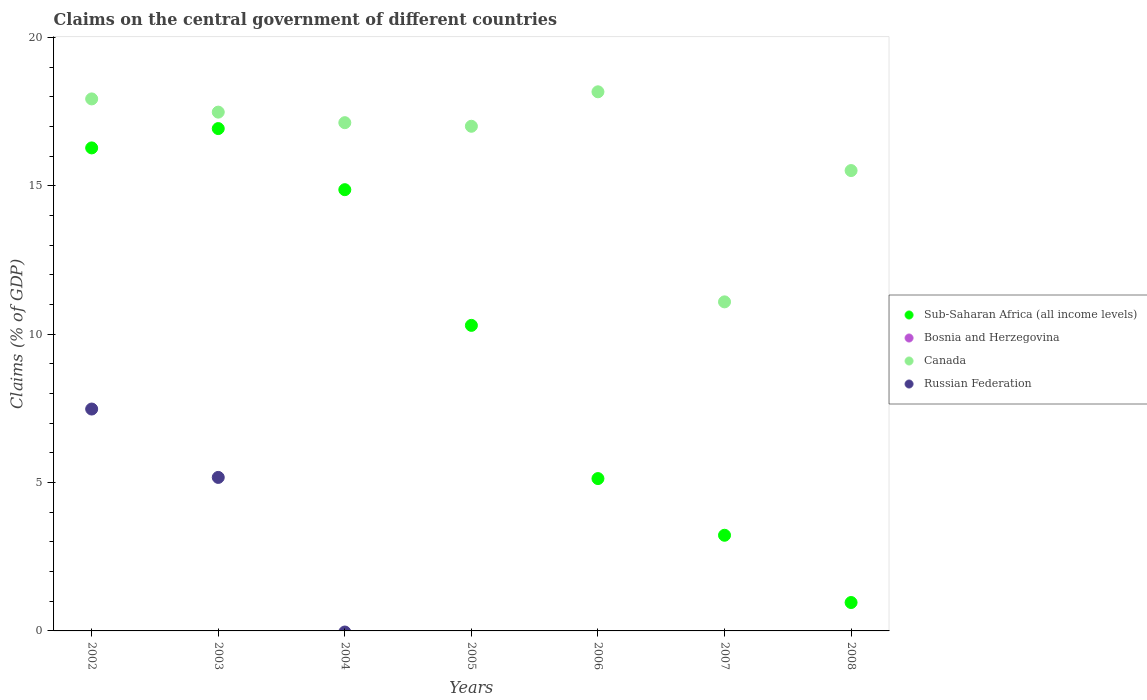What is the percentage of GDP claimed on the central government in Canada in 2004?
Give a very brief answer. 17.13. Across all years, what is the maximum percentage of GDP claimed on the central government in Russian Federation?
Make the answer very short. 7.48. Across all years, what is the minimum percentage of GDP claimed on the central government in Canada?
Your response must be concise. 11.09. What is the total percentage of GDP claimed on the central government in Canada in the graph?
Your answer should be compact. 114.3. What is the difference between the percentage of GDP claimed on the central government in Sub-Saharan Africa (all income levels) in 2007 and that in 2008?
Offer a very short reply. 2.27. What is the difference between the percentage of GDP claimed on the central government in Bosnia and Herzegovina in 2002 and the percentage of GDP claimed on the central government in Canada in 2007?
Your answer should be very brief. -11.09. What is the average percentage of GDP claimed on the central government in Canada per year?
Offer a very short reply. 16.33. In the year 2004, what is the difference between the percentage of GDP claimed on the central government in Sub-Saharan Africa (all income levels) and percentage of GDP claimed on the central government in Canada?
Give a very brief answer. -2.26. In how many years, is the percentage of GDP claimed on the central government in Canada greater than 19 %?
Provide a short and direct response. 0. What is the ratio of the percentage of GDP claimed on the central government in Sub-Saharan Africa (all income levels) in 2002 to that in 2005?
Offer a very short reply. 1.58. What is the difference between the highest and the second highest percentage of GDP claimed on the central government in Sub-Saharan Africa (all income levels)?
Your answer should be compact. 0.65. What is the difference between the highest and the lowest percentage of GDP claimed on the central government in Canada?
Provide a succinct answer. 7.08. Is it the case that in every year, the sum of the percentage of GDP claimed on the central government in Sub-Saharan Africa (all income levels) and percentage of GDP claimed on the central government in Russian Federation  is greater than the sum of percentage of GDP claimed on the central government in Canada and percentage of GDP claimed on the central government in Bosnia and Herzegovina?
Your answer should be very brief. No. Does the percentage of GDP claimed on the central government in Canada monotonically increase over the years?
Give a very brief answer. No. How many years are there in the graph?
Keep it short and to the point. 7. What is the difference between two consecutive major ticks on the Y-axis?
Ensure brevity in your answer.  5. Does the graph contain grids?
Offer a terse response. No. How many legend labels are there?
Give a very brief answer. 4. How are the legend labels stacked?
Keep it short and to the point. Vertical. What is the title of the graph?
Provide a short and direct response. Claims on the central government of different countries. Does "Faeroe Islands" appear as one of the legend labels in the graph?
Make the answer very short. No. What is the label or title of the Y-axis?
Provide a short and direct response. Claims (% of GDP). What is the Claims (% of GDP) in Sub-Saharan Africa (all income levels) in 2002?
Give a very brief answer. 16.28. What is the Claims (% of GDP) of Bosnia and Herzegovina in 2002?
Your response must be concise. 0. What is the Claims (% of GDP) in Canada in 2002?
Offer a terse response. 17.93. What is the Claims (% of GDP) of Russian Federation in 2002?
Your answer should be compact. 7.48. What is the Claims (% of GDP) in Sub-Saharan Africa (all income levels) in 2003?
Your answer should be compact. 16.93. What is the Claims (% of GDP) in Bosnia and Herzegovina in 2003?
Provide a succinct answer. 0. What is the Claims (% of GDP) in Canada in 2003?
Give a very brief answer. 17.48. What is the Claims (% of GDP) of Russian Federation in 2003?
Your answer should be very brief. 5.17. What is the Claims (% of GDP) in Sub-Saharan Africa (all income levels) in 2004?
Provide a short and direct response. 14.87. What is the Claims (% of GDP) of Canada in 2004?
Your response must be concise. 17.13. What is the Claims (% of GDP) of Russian Federation in 2004?
Your response must be concise. 0. What is the Claims (% of GDP) of Sub-Saharan Africa (all income levels) in 2005?
Your answer should be compact. 10.3. What is the Claims (% of GDP) of Canada in 2005?
Keep it short and to the point. 17. What is the Claims (% of GDP) in Russian Federation in 2005?
Give a very brief answer. 0. What is the Claims (% of GDP) in Sub-Saharan Africa (all income levels) in 2006?
Your response must be concise. 5.13. What is the Claims (% of GDP) in Canada in 2006?
Give a very brief answer. 18.17. What is the Claims (% of GDP) of Sub-Saharan Africa (all income levels) in 2007?
Offer a terse response. 3.22. What is the Claims (% of GDP) in Bosnia and Herzegovina in 2007?
Your answer should be compact. 0. What is the Claims (% of GDP) of Canada in 2007?
Ensure brevity in your answer.  11.09. What is the Claims (% of GDP) of Sub-Saharan Africa (all income levels) in 2008?
Your response must be concise. 0.96. What is the Claims (% of GDP) in Bosnia and Herzegovina in 2008?
Your response must be concise. 0. What is the Claims (% of GDP) of Canada in 2008?
Your answer should be compact. 15.51. Across all years, what is the maximum Claims (% of GDP) of Sub-Saharan Africa (all income levels)?
Your answer should be very brief. 16.93. Across all years, what is the maximum Claims (% of GDP) of Canada?
Your answer should be compact. 18.17. Across all years, what is the maximum Claims (% of GDP) of Russian Federation?
Your answer should be very brief. 7.48. Across all years, what is the minimum Claims (% of GDP) in Sub-Saharan Africa (all income levels)?
Offer a terse response. 0.96. Across all years, what is the minimum Claims (% of GDP) of Canada?
Provide a succinct answer. 11.09. Across all years, what is the minimum Claims (% of GDP) in Russian Federation?
Make the answer very short. 0. What is the total Claims (% of GDP) in Sub-Saharan Africa (all income levels) in the graph?
Offer a terse response. 67.68. What is the total Claims (% of GDP) in Canada in the graph?
Offer a terse response. 114.3. What is the total Claims (% of GDP) in Russian Federation in the graph?
Your response must be concise. 12.65. What is the difference between the Claims (% of GDP) of Sub-Saharan Africa (all income levels) in 2002 and that in 2003?
Your answer should be compact. -0.65. What is the difference between the Claims (% of GDP) in Canada in 2002 and that in 2003?
Give a very brief answer. 0.45. What is the difference between the Claims (% of GDP) in Russian Federation in 2002 and that in 2003?
Your answer should be very brief. 2.3. What is the difference between the Claims (% of GDP) of Sub-Saharan Africa (all income levels) in 2002 and that in 2004?
Make the answer very short. 1.41. What is the difference between the Claims (% of GDP) of Canada in 2002 and that in 2004?
Provide a short and direct response. 0.8. What is the difference between the Claims (% of GDP) of Sub-Saharan Africa (all income levels) in 2002 and that in 2005?
Give a very brief answer. 5.98. What is the difference between the Claims (% of GDP) of Canada in 2002 and that in 2005?
Keep it short and to the point. 0.92. What is the difference between the Claims (% of GDP) in Sub-Saharan Africa (all income levels) in 2002 and that in 2006?
Offer a very short reply. 11.14. What is the difference between the Claims (% of GDP) of Canada in 2002 and that in 2006?
Ensure brevity in your answer.  -0.24. What is the difference between the Claims (% of GDP) in Sub-Saharan Africa (all income levels) in 2002 and that in 2007?
Provide a succinct answer. 13.05. What is the difference between the Claims (% of GDP) of Canada in 2002 and that in 2007?
Give a very brief answer. 6.84. What is the difference between the Claims (% of GDP) in Sub-Saharan Africa (all income levels) in 2002 and that in 2008?
Ensure brevity in your answer.  15.32. What is the difference between the Claims (% of GDP) in Canada in 2002 and that in 2008?
Offer a terse response. 2.41. What is the difference between the Claims (% of GDP) in Sub-Saharan Africa (all income levels) in 2003 and that in 2004?
Your answer should be very brief. 2.06. What is the difference between the Claims (% of GDP) of Canada in 2003 and that in 2004?
Ensure brevity in your answer.  0.36. What is the difference between the Claims (% of GDP) of Sub-Saharan Africa (all income levels) in 2003 and that in 2005?
Your answer should be compact. 6.63. What is the difference between the Claims (% of GDP) of Canada in 2003 and that in 2005?
Ensure brevity in your answer.  0.48. What is the difference between the Claims (% of GDP) in Sub-Saharan Africa (all income levels) in 2003 and that in 2006?
Your answer should be very brief. 11.79. What is the difference between the Claims (% of GDP) of Canada in 2003 and that in 2006?
Ensure brevity in your answer.  -0.68. What is the difference between the Claims (% of GDP) in Sub-Saharan Africa (all income levels) in 2003 and that in 2007?
Offer a very short reply. 13.7. What is the difference between the Claims (% of GDP) of Canada in 2003 and that in 2007?
Offer a terse response. 6.39. What is the difference between the Claims (% of GDP) of Sub-Saharan Africa (all income levels) in 2003 and that in 2008?
Give a very brief answer. 15.97. What is the difference between the Claims (% of GDP) of Canada in 2003 and that in 2008?
Your answer should be compact. 1.97. What is the difference between the Claims (% of GDP) of Sub-Saharan Africa (all income levels) in 2004 and that in 2005?
Your answer should be compact. 4.57. What is the difference between the Claims (% of GDP) of Canada in 2004 and that in 2005?
Ensure brevity in your answer.  0.12. What is the difference between the Claims (% of GDP) in Sub-Saharan Africa (all income levels) in 2004 and that in 2006?
Your answer should be compact. 9.73. What is the difference between the Claims (% of GDP) in Canada in 2004 and that in 2006?
Keep it short and to the point. -1.04. What is the difference between the Claims (% of GDP) of Sub-Saharan Africa (all income levels) in 2004 and that in 2007?
Provide a succinct answer. 11.64. What is the difference between the Claims (% of GDP) of Canada in 2004 and that in 2007?
Provide a succinct answer. 6.04. What is the difference between the Claims (% of GDP) in Sub-Saharan Africa (all income levels) in 2004 and that in 2008?
Provide a succinct answer. 13.91. What is the difference between the Claims (% of GDP) in Canada in 2004 and that in 2008?
Ensure brevity in your answer.  1.61. What is the difference between the Claims (% of GDP) of Sub-Saharan Africa (all income levels) in 2005 and that in 2006?
Make the answer very short. 5.16. What is the difference between the Claims (% of GDP) of Canada in 2005 and that in 2006?
Make the answer very short. -1.16. What is the difference between the Claims (% of GDP) in Sub-Saharan Africa (all income levels) in 2005 and that in 2007?
Your answer should be compact. 7.07. What is the difference between the Claims (% of GDP) of Canada in 2005 and that in 2007?
Offer a very short reply. 5.92. What is the difference between the Claims (% of GDP) of Sub-Saharan Africa (all income levels) in 2005 and that in 2008?
Give a very brief answer. 9.34. What is the difference between the Claims (% of GDP) in Canada in 2005 and that in 2008?
Your answer should be compact. 1.49. What is the difference between the Claims (% of GDP) of Sub-Saharan Africa (all income levels) in 2006 and that in 2007?
Your answer should be compact. 1.91. What is the difference between the Claims (% of GDP) of Canada in 2006 and that in 2007?
Offer a terse response. 7.08. What is the difference between the Claims (% of GDP) in Sub-Saharan Africa (all income levels) in 2006 and that in 2008?
Your answer should be very brief. 4.18. What is the difference between the Claims (% of GDP) in Canada in 2006 and that in 2008?
Give a very brief answer. 2.65. What is the difference between the Claims (% of GDP) of Sub-Saharan Africa (all income levels) in 2007 and that in 2008?
Your answer should be very brief. 2.27. What is the difference between the Claims (% of GDP) in Canada in 2007 and that in 2008?
Ensure brevity in your answer.  -4.42. What is the difference between the Claims (% of GDP) of Sub-Saharan Africa (all income levels) in 2002 and the Claims (% of GDP) of Canada in 2003?
Offer a very short reply. -1.21. What is the difference between the Claims (% of GDP) of Sub-Saharan Africa (all income levels) in 2002 and the Claims (% of GDP) of Russian Federation in 2003?
Your answer should be compact. 11.1. What is the difference between the Claims (% of GDP) of Canada in 2002 and the Claims (% of GDP) of Russian Federation in 2003?
Ensure brevity in your answer.  12.75. What is the difference between the Claims (% of GDP) of Sub-Saharan Africa (all income levels) in 2002 and the Claims (% of GDP) of Canada in 2004?
Offer a very short reply. -0.85. What is the difference between the Claims (% of GDP) of Sub-Saharan Africa (all income levels) in 2002 and the Claims (% of GDP) of Canada in 2005?
Make the answer very short. -0.73. What is the difference between the Claims (% of GDP) of Sub-Saharan Africa (all income levels) in 2002 and the Claims (% of GDP) of Canada in 2006?
Provide a succinct answer. -1.89. What is the difference between the Claims (% of GDP) of Sub-Saharan Africa (all income levels) in 2002 and the Claims (% of GDP) of Canada in 2007?
Ensure brevity in your answer.  5.19. What is the difference between the Claims (% of GDP) in Sub-Saharan Africa (all income levels) in 2002 and the Claims (% of GDP) in Canada in 2008?
Provide a succinct answer. 0.76. What is the difference between the Claims (% of GDP) in Sub-Saharan Africa (all income levels) in 2003 and the Claims (% of GDP) in Canada in 2004?
Provide a succinct answer. -0.2. What is the difference between the Claims (% of GDP) in Sub-Saharan Africa (all income levels) in 2003 and the Claims (% of GDP) in Canada in 2005?
Give a very brief answer. -0.08. What is the difference between the Claims (% of GDP) of Sub-Saharan Africa (all income levels) in 2003 and the Claims (% of GDP) of Canada in 2006?
Offer a very short reply. -1.24. What is the difference between the Claims (% of GDP) in Sub-Saharan Africa (all income levels) in 2003 and the Claims (% of GDP) in Canada in 2007?
Keep it short and to the point. 5.84. What is the difference between the Claims (% of GDP) in Sub-Saharan Africa (all income levels) in 2003 and the Claims (% of GDP) in Canada in 2008?
Provide a short and direct response. 1.41. What is the difference between the Claims (% of GDP) of Sub-Saharan Africa (all income levels) in 2004 and the Claims (% of GDP) of Canada in 2005?
Ensure brevity in your answer.  -2.14. What is the difference between the Claims (% of GDP) in Sub-Saharan Africa (all income levels) in 2004 and the Claims (% of GDP) in Canada in 2006?
Your answer should be compact. -3.3. What is the difference between the Claims (% of GDP) of Sub-Saharan Africa (all income levels) in 2004 and the Claims (% of GDP) of Canada in 2007?
Keep it short and to the point. 3.78. What is the difference between the Claims (% of GDP) in Sub-Saharan Africa (all income levels) in 2004 and the Claims (% of GDP) in Canada in 2008?
Offer a very short reply. -0.64. What is the difference between the Claims (% of GDP) in Sub-Saharan Africa (all income levels) in 2005 and the Claims (% of GDP) in Canada in 2006?
Provide a succinct answer. -7.87. What is the difference between the Claims (% of GDP) in Sub-Saharan Africa (all income levels) in 2005 and the Claims (% of GDP) in Canada in 2007?
Make the answer very short. -0.79. What is the difference between the Claims (% of GDP) of Sub-Saharan Africa (all income levels) in 2005 and the Claims (% of GDP) of Canada in 2008?
Offer a terse response. -5.22. What is the difference between the Claims (% of GDP) in Sub-Saharan Africa (all income levels) in 2006 and the Claims (% of GDP) in Canada in 2007?
Your response must be concise. -5.95. What is the difference between the Claims (% of GDP) of Sub-Saharan Africa (all income levels) in 2006 and the Claims (% of GDP) of Canada in 2008?
Keep it short and to the point. -10.38. What is the difference between the Claims (% of GDP) of Sub-Saharan Africa (all income levels) in 2007 and the Claims (% of GDP) of Canada in 2008?
Give a very brief answer. -12.29. What is the average Claims (% of GDP) of Sub-Saharan Africa (all income levels) per year?
Your response must be concise. 9.67. What is the average Claims (% of GDP) of Bosnia and Herzegovina per year?
Make the answer very short. 0. What is the average Claims (% of GDP) of Canada per year?
Ensure brevity in your answer.  16.33. What is the average Claims (% of GDP) in Russian Federation per year?
Provide a short and direct response. 1.81. In the year 2002, what is the difference between the Claims (% of GDP) in Sub-Saharan Africa (all income levels) and Claims (% of GDP) in Canada?
Your answer should be very brief. -1.65. In the year 2002, what is the difference between the Claims (% of GDP) of Sub-Saharan Africa (all income levels) and Claims (% of GDP) of Russian Federation?
Offer a very short reply. 8.8. In the year 2002, what is the difference between the Claims (% of GDP) of Canada and Claims (% of GDP) of Russian Federation?
Provide a short and direct response. 10.45. In the year 2003, what is the difference between the Claims (% of GDP) in Sub-Saharan Africa (all income levels) and Claims (% of GDP) in Canada?
Offer a very short reply. -0.55. In the year 2003, what is the difference between the Claims (% of GDP) in Sub-Saharan Africa (all income levels) and Claims (% of GDP) in Russian Federation?
Your answer should be very brief. 11.75. In the year 2003, what is the difference between the Claims (% of GDP) in Canada and Claims (% of GDP) in Russian Federation?
Your response must be concise. 12.31. In the year 2004, what is the difference between the Claims (% of GDP) in Sub-Saharan Africa (all income levels) and Claims (% of GDP) in Canada?
Give a very brief answer. -2.26. In the year 2005, what is the difference between the Claims (% of GDP) of Sub-Saharan Africa (all income levels) and Claims (% of GDP) of Canada?
Keep it short and to the point. -6.71. In the year 2006, what is the difference between the Claims (% of GDP) in Sub-Saharan Africa (all income levels) and Claims (% of GDP) in Canada?
Ensure brevity in your answer.  -13.03. In the year 2007, what is the difference between the Claims (% of GDP) of Sub-Saharan Africa (all income levels) and Claims (% of GDP) of Canada?
Provide a short and direct response. -7.86. In the year 2008, what is the difference between the Claims (% of GDP) of Sub-Saharan Africa (all income levels) and Claims (% of GDP) of Canada?
Your answer should be very brief. -14.55. What is the ratio of the Claims (% of GDP) of Sub-Saharan Africa (all income levels) in 2002 to that in 2003?
Offer a very short reply. 0.96. What is the ratio of the Claims (% of GDP) in Canada in 2002 to that in 2003?
Offer a very short reply. 1.03. What is the ratio of the Claims (% of GDP) of Russian Federation in 2002 to that in 2003?
Your response must be concise. 1.45. What is the ratio of the Claims (% of GDP) in Sub-Saharan Africa (all income levels) in 2002 to that in 2004?
Ensure brevity in your answer.  1.09. What is the ratio of the Claims (% of GDP) of Canada in 2002 to that in 2004?
Provide a short and direct response. 1.05. What is the ratio of the Claims (% of GDP) of Sub-Saharan Africa (all income levels) in 2002 to that in 2005?
Provide a short and direct response. 1.58. What is the ratio of the Claims (% of GDP) in Canada in 2002 to that in 2005?
Your answer should be very brief. 1.05. What is the ratio of the Claims (% of GDP) in Sub-Saharan Africa (all income levels) in 2002 to that in 2006?
Ensure brevity in your answer.  3.17. What is the ratio of the Claims (% of GDP) of Canada in 2002 to that in 2006?
Your answer should be very brief. 0.99. What is the ratio of the Claims (% of GDP) of Sub-Saharan Africa (all income levels) in 2002 to that in 2007?
Offer a terse response. 5.05. What is the ratio of the Claims (% of GDP) in Canada in 2002 to that in 2007?
Provide a short and direct response. 1.62. What is the ratio of the Claims (% of GDP) in Sub-Saharan Africa (all income levels) in 2002 to that in 2008?
Offer a terse response. 17.01. What is the ratio of the Claims (% of GDP) in Canada in 2002 to that in 2008?
Ensure brevity in your answer.  1.16. What is the ratio of the Claims (% of GDP) in Sub-Saharan Africa (all income levels) in 2003 to that in 2004?
Offer a very short reply. 1.14. What is the ratio of the Claims (% of GDP) in Canada in 2003 to that in 2004?
Make the answer very short. 1.02. What is the ratio of the Claims (% of GDP) in Sub-Saharan Africa (all income levels) in 2003 to that in 2005?
Provide a succinct answer. 1.64. What is the ratio of the Claims (% of GDP) in Canada in 2003 to that in 2005?
Offer a very short reply. 1.03. What is the ratio of the Claims (% of GDP) in Sub-Saharan Africa (all income levels) in 2003 to that in 2006?
Keep it short and to the point. 3.3. What is the ratio of the Claims (% of GDP) of Canada in 2003 to that in 2006?
Give a very brief answer. 0.96. What is the ratio of the Claims (% of GDP) of Sub-Saharan Africa (all income levels) in 2003 to that in 2007?
Your answer should be very brief. 5.25. What is the ratio of the Claims (% of GDP) in Canada in 2003 to that in 2007?
Your answer should be compact. 1.58. What is the ratio of the Claims (% of GDP) of Sub-Saharan Africa (all income levels) in 2003 to that in 2008?
Keep it short and to the point. 17.69. What is the ratio of the Claims (% of GDP) in Canada in 2003 to that in 2008?
Offer a very short reply. 1.13. What is the ratio of the Claims (% of GDP) of Sub-Saharan Africa (all income levels) in 2004 to that in 2005?
Your response must be concise. 1.44. What is the ratio of the Claims (% of GDP) in Canada in 2004 to that in 2005?
Make the answer very short. 1.01. What is the ratio of the Claims (% of GDP) in Sub-Saharan Africa (all income levels) in 2004 to that in 2006?
Offer a very short reply. 2.9. What is the ratio of the Claims (% of GDP) in Canada in 2004 to that in 2006?
Ensure brevity in your answer.  0.94. What is the ratio of the Claims (% of GDP) in Sub-Saharan Africa (all income levels) in 2004 to that in 2007?
Offer a very short reply. 4.61. What is the ratio of the Claims (% of GDP) in Canada in 2004 to that in 2007?
Provide a succinct answer. 1.54. What is the ratio of the Claims (% of GDP) of Sub-Saharan Africa (all income levels) in 2004 to that in 2008?
Make the answer very short. 15.54. What is the ratio of the Claims (% of GDP) of Canada in 2004 to that in 2008?
Ensure brevity in your answer.  1.1. What is the ratio of the Claims (% of GDP) in Sub-Saharan Africa (all income levels) in 2005 to that in 2006?
Give a very brief answer. 2.01. What is the ratio of the Claims (% of GDP) in Canada in 2005 to that in 2006?
Provide a succinct answer. 0.94. What is the ratio of the Claims (% of GDP) in Sub-Saharan Africa (all income levels) in 2005 to that in 2007?
Provide a short and direct response. 3.19. What is the ratio of the Claims (% of GDP) in Canada in 2005 to that in 2007?
Your answer should be very brief. 1.53. What is the ratio of the Claims (% of GDP) of Sub-Saharan Africa (all income levels) in 2005 to that in 2008?
Make the answer very short. 10.76. What is the ratio of the Claims (% of GDP) in Canada in 2005 to that in 2008?
Provide a succinct answer. 1.1. What is the ratio of the Claims (% of GDP) of Sub-Saharan Africa (all income levels) in 2006 to that in 2007?
Ensure brevity in your answer.  1.59. What is the ratio of the Claims (% of GDP) of Canada in 2006 to that in 2007?
Your response must be concise. 1.64. What is the ratio of the Claims (% of GDP) of Sub-Saharan Africa (all income levels) in 2006 to that in 2008?
Your response must be concise. 5.37. What is the ratio of the Claims (% of GDP) in Canada in 2006 to that in 2008?
Your answer should be very brief. 1.17. What is the ratio of the Claims (% of GDP) in Sub-Saharan Africa (all income levels) in 2007 to that in 2008?
Make the answer very short. 3.37. What is the ratio of the Claims (% of GDP) of Canada in 2007 to that in 2008?
Offer a very short reply. 0.71. What is the difference between the highest and the second highest Claims (% of GDP) of Sub-Saharan Africa (all income levels)?
Keep it short and to the point. 0.65. What is the difference between the highest and the second highest Claims (% of GDP) of Canada?
Ensure brevity in your answer.  0.24. What is the difference between the highest and the lowest Claims (% of GDP) in Sub-Saharan Africa (all income levels)?
Your answer should be compact. 15.97. What is the difference between the highest and the lowest Claims (% of GDP) in Canada?
Ensure brevity in your answer.  7.08. What is the difference between the highest and the lowest Claims (% of GDP) in Russian Federation?
Make the answer very short. 7.48. 